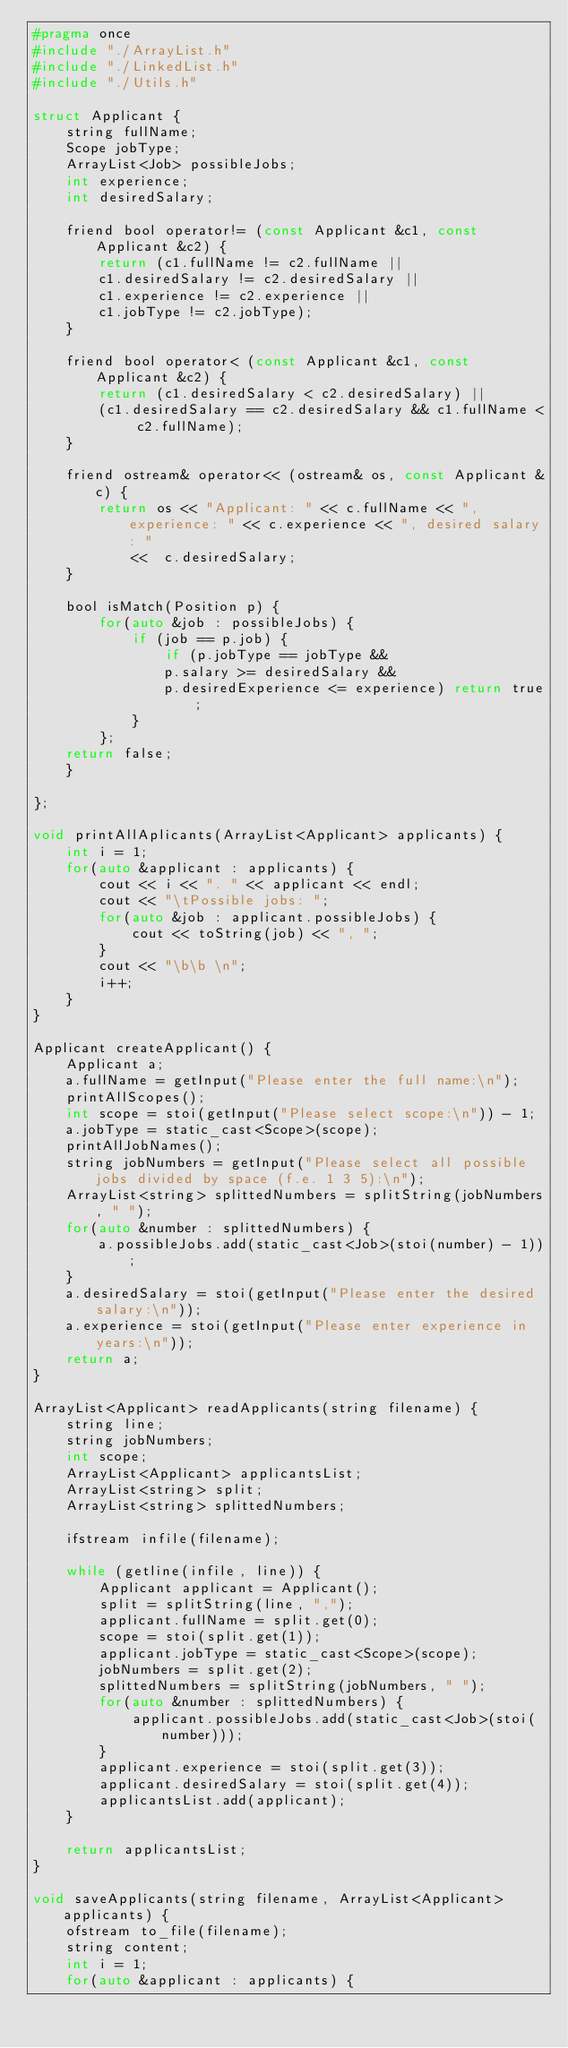Convert code to text. <code><loc_0><loc_0><loc_500><loc_500><_C_>#pragma once
#include "./ArrayList.h"
#include "./LinkedList.h"
#include "./Utils.h"

struct Applicant {
    string fullName;
    Scope jobType;
    ArrayList<Job> possibleJobs;
    int experience;
    int desiredSalary;

    friend bool operator!= (const Applicant &c1, const Applicant &c2) {
        return (c1.fullName != c2.fullName || 
        c1.desiredSalary != c2.desiredSalary ||
        c1.experience != c2.experience ||
        c1.jobType != c2.jobType);
    }

    friend bool operator< (const Applicant &c1, const Applicant &c2) {
        return (c1.desiredSalary < c2.desiredSalary) ||
        (c1.desiredSalary == c2.desiredSalary && c1.fullName < c2.fullName);
    }

    friend ostream& operator<< (ostream& os, const Applicant &c) {
        return os << "Applicant: " << c.fullName << ", experience: " << c.experience << ", desired salary: " 
            <<  c.desiredSalary;
    }

    bool isMatch(Position p) {
        for(auto &job : possibleJobs) {
            if (job == p.job) {
                if (p.jobType == jobType &&
                p.salary >= desiredSalary &&
                p.desiredExperience <= experience) return true;
            }
        };
    return false;
    }
    
};

void printAllAplicants(ArrayList<Applicant> applicants) {
    int i = 1;
    for(auto &applicant : applicants) {
        cout << i << ". " << applicant << endl;
        cout << "\tPossible jobs: ";
        for(auto &job : applicant.possibleJobs) {
            cout << toString(job) << ", ";
        }
        cout << "\b\b \n";
        i++;
    }
}

Applicant createApplicant() {
    Applicant a;
    a.fullName = getInput("Please enter the full name:\n");
    printAllScopes();
    int scope = stoi(getInput("Please select scope:\n")) - 1;
    a.jobType = static_cast<Scope>(scope);
    printAllJobNames();
    string jobNumbers = getInput("Please select all possible jobs divided by space (f.e. 1 3 5):\n");
    ArrayList<string> splittedNumbers = splitString(jobNumbers, " ");
    for(auto &number : splittedNumbers) {
        a.possibleJobs.add(static_cast<Job>(stoi(number) - 1));
    }
    a.desiredSalary = stoi(getInput("Please enter the desired salary:\n"));
    a.experience = stoi(getInput("Please enter experience in years:\n"));
    return a;
}

ArrayList<Applicant> readApplicants(string filename) {
    string line;
    string jobNumbers;
    int scope;
    ArrayList<Applicant> applicantsList;
    ArrayList<string> split;
    ArrayList<string> splittedNumbers;

    ifstream infile(filename);
    
    while (getline(infile, line)) {
        Applicant applicant = Applicant();
        split = splitString(line, ",");
        applicant.fullName = split.get(0);
        scope = stoi(split.get(1));
        applicant.jobType = static_cast<Scope>(scope);
        jobNumbers = split.get(2);
        splittedNumbers = splitString(jobNumbers, " ");
        for(auto &number : splittedNumbers) {
            applicant.possibleJobs.add(static_cast<Job>(stoi(number)));
        }
        applicant.experience = stoi(split.get(3));
        applicant.desiredSalary = stoi(split.get(4));
        applicantsList.add(applicant);
    }

    return applicantsList;
}

void saveApplicants(string filename, ArrayList<Applicant> applicants) {
    ofstream to_file(filename);
    string content;
    int i = 1;
    for(auto &applicant : applicants) {</code> 